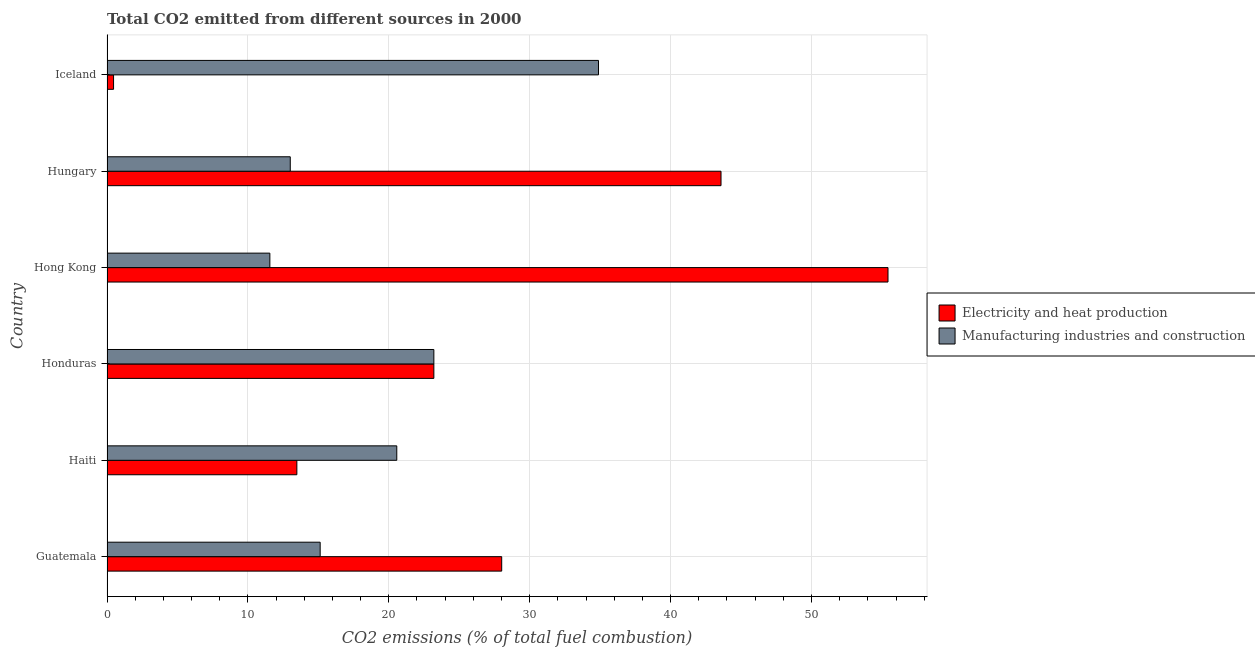How many different coloured bars are there?
Your answer should be compact. 2. How many groups of bars are there?
Your answer should be very brief. 6. What is the label of the 1st group of bars from the top?
Give a very brief answer. Iceland. In how many cases, is the number of bars for a given country not equal to the number of legend labels?
Your answer should be compact. 0. What is the co2 emissions due to electricity and heat production in Hong Kong?
Your answer should be very brief. 55.43. Across all countries, what is the maximum co2 emissions due to manufacturing industries?
Make the answer very short. 34.88. Across all countries, what is the minimum co2 emissions due to manufacturing industries?
Offer a terse response. 11.56. In which country was the co2 emissions due to manufacturing industries maximum?
Offer a terse response. Iceland. What is the total co2 emissions due to manufacturing industries in the graph?
Provide a succinct answer. 118.35. What is the difference between the co2 emissions due to manufacturing industries in Guatemala and that in Hong Kong?
Make the answer very short. 3.57. What is the difference between the co2 emissions due to manufacturing industries in Guatemala and the co2 emissions due to electricity and heat production in Iceland?
Make the answer very short. 14.66. What is the average co2 emissions due to electricity and heat production per country?
Your answer should be very brief. 27.36. What is the difference between the co2 emissions due to manufacturing industries and co2 emissions due to electricity and heat production in Haiti?
Ensure brevity in your answer.  7.09. What is the ratio of the co2 emissions due to electricity and heat production in Haiti to that in Hong Kong?
Offer a very short reply. 0.24. Is the co2 emissions due to electricity and heat production in Honduras less than that in Hong Kong?
Your answer should be compact. Yes. What is the difference between the highest and the second highest co2 emissions due to electricity and heat production?
Ensure brevity in your answer.  11.85. What is the difference between the highest and the lowest co2 emissions due to manufacturing industries?
Ensure brevity in your answer.  23.33. Is the sum of the co2 emissions due to electricity and heat production in Haiti and Hong Kong greater than the maximum co2 emissions due to manufacturing industries across all countries?
Your answer should be compact. Yes. What does the 2nd bar from the top in Hungary represents?
Give a very brief answer. Electricity and heat production. What does the 1st bar from the bottom in Guatemala represents?
Your response must be concise. Electricity and heat production. How many bars are there?
Ensure brevity in your answer.  12. How many countries are there in the graph?
Keep it short and to the point. 6. What is the difference between two consecutive major ticks on the X-axis?
Your answer should be compact. 10. Does the graph contain grids?
Offer a very short reply. Yes. What is the title of the graph?
Your answer should be very brief. Total CO2 emitted from different sources in 2000. Does "Male labor force" appear as one of the legend labels in the graph?
Your answer should be compact. No. What is the label or title of the X-axis?
Keep it short and to the point. CO2 emissions (% of total fuel combustion). What is the CO2 emissions (% of total fuel combustion) of Electricity and heat production in Guatemala?
Keep it short and to the point. 28.01. What is the CO2 emissions (% of total fuel combustion) of Manufacturing industries and construction in Guatemala?
Make the answer very short. 15.13. What is the CO2 emissions (% of total fuel combustion) in Electricity and heat production in Haiti?
Offer a terse response. 13.48. What is the CO2 emissions (% of total fuel combustion) of Manufacturing industries and construction in Haiti?
Provide a short and direct response. 20.57. What is the CO2 emissions (% of total fuel combustion) in Electricity and heat production in Honduras?
Your answer should be compact. 23.2. What is the CO2 emissions (% of total fuel combustion) in Manufacturing industries and construction in Honduras?
Give a very brief answer. 23.2. What is the CO2 emissions (% of total fuel combustion) of Electricity and heat production in Hong Kong?
Provide a short and direct response. 55.43. What is the CO2 emissions (% of total fuel combustion) in Manufacturing industries and construction in Hong Kong?
Your answer should be compact. 11.56. What is the CO2 emissions (% of total fuel combustion) in Electricity and heat production in Hungary?
Provide a succinct answer. 43.58. What is the CO2 emissions (% of total fuel combustion) in Manufacturing industries and construction in Hungary?
Give a very brief answer. 13.01. What is the CO2 emissions (% of total fuel combustion) in Electricity and heat production in Iceland?
Give a very brief answer. 0.47. What is the CO2 emissions (% of total fuel combustion) in Manufacturing industries and construction in Iceland?
Provide a short and direct response. 34.88. Across all countries, what is the maximum CO2 emissions (% of total fuel combustion) of Electricity and heat production?
Offer a very short reply. 55.43. Across all countries, what is the maximum CO2 emissions (% of total fuel combustion) of Manufacturing industries and construction?
Provide a short and direct response. 34.88. Across all countries, what is the minimum CO2 emissions (% of total fuel combustion) in Electricity and heat production?
Make the answer very short. 0.47. Across all countries, what is the minimum CO2 emissions (% of total fuel combustion) in Manufacturing industries and construction?
Provide a short and direct response. 11.56. What is the total CO2 emissions (% of total fuel combustion) of Electricity and heat production in the graph?
Your response must be concise. 164.16. What is the total CO2 emissions (% of total fuel combustion) of Manufacturing industries and construction in the graph?
Offer a very short reply. 118.35. What is the difference between the CO2 emissions (% of total fuel combustion) in Electricity and heat production in Guatemala and that in Haiti?
Give a very brief answer. 14.54. What is the difference between the CO2 emissions (% of total fuel combustion) in Manufacturing industries and construction in Guatemala and that in Haiti?
Provide a short and direct response. -5.44. What is the difference between the CO2 emissions (% of total fuel combustion) of Electricity and heat production in Guatemala and that in Honduras?
Keep it short and to the point. 4.82. What is the difference between the CO2 emissions (% of total fuel combustion) in Manufacturing industries and construction in Guatemala and that in Honduras?
Offer a very short reply. -8.07. What is the difference between the CO2 emissions (% of total fuel combustion) of Electricity and heat production in Guatemala and that in Hong Kong?
Provide a succinct answer. -27.42. What is the difference between the CO2 emissions (% of total fuel combustion) in Manufacturing industries and construction in Guatemala and that in Hong Kong?
Give a very brief answer. 3.57. What is the difference between the CO2 emissions (% of total fuel combustion) in Electricity and heat production in Guatemala and that in Hungary?
Provide a short and direct response. -15.57. What is the difference between the CO2 emissions (% of total fuel combustion) of Manufacturing industries and construction in Guatemala and that in Hungary?
Your answer should be compact. 2.12. What is the difference between the CO2 emissions (% of total fuel combustion) in Electricity and heat production in Guatemala and that in Iceland?
Your answer should be very brief. 27.55. What is the difference between the CO2 emissions (% of total fuel combustion) of Manufacturing industries and construction in Guatemala and that in Iceland?
Keep it short and to the point. -19.75. What is the difference between the CO2 emissions (% of total fuel combustion) in Electricity and heat production in Haiti and that in Honduras?
Offer a terse response. -9.72. What is the difference between the CO2 emissions (% of total fuel combustion) of Manufacturing industries and construction in Haiti and that in Honduras?
Ensure brevity in your answer.  -2.63. What is the difference between the CO2 emissions (% of total fuel combustion) in Electricity and heat production in Haiti and that in Hong Kong?
Ensure brevity in your answer.  -41.96. What is the difference between the CO2 emissions (% of total fuel combustion) of Manufacturing industries and construction in Haiti and that in Hong Kong?
Your answer should be compact. 9.01. What is the difference between the CO2 emissions (% of total fuel combustion) of Electricity and heat production in Haiti and that in Hungary?
Ensure brevity in your answer.  -30.1. What is the difference between the CO2 emissions (% of total fuel combustion) in Manufacturing industries and construction in Haiti and that in Hungary?
Make the answer very short. 7.56. What is the difference between the CO2 emissions (% of total fuel combustion) in Electricity and heat production in Haiti and that in Iceland?
Ensure brevity in your answer.  13.01. What is the difference between the CO2 emissions (% of total fuel combustion) of Manufacturing industries and construction in Haiti and that in Iceland?
Keep it short and to the point. -14.32. What is the difference between the CO2 emissions (% of total fuel combustion) in Electricity and heat production in Honduras and that in Hong Kong?
Offer a terse response. -32.23. What is the difference between the CO2 emissions (% of total fuel combustion) in Manufacturing industries and construction in Honduras and that in Hong Kong?
Offer a terse response. 11.64. What is the difference between the CO2 emissions (% of total fuel combustion) in Electricity and heat production in Honduras and that in Hungary?
Ensure brevity in your answer.  -20.38. What is the difference between the CO2 emissions (% of total fuel combustion) of Manufacturing industries and construction in Honduras and that in Hungary?
Offer a very short reply. 10.19. What is the difference between the CO2 emissions (% of total fuel combustion) of Electricity and heat production in Honduras and that in Iceland?
Your response must be concise. 22.73. What is the difference between the CO2 emissions (% of total fuel combustion) of Manufacturing industries and construction in Honduras and that in Iceland?
Your answer should be compact. -11.69. What is the difference between the CO2 emissions (% of total fuel combustion) of Electricity and heat production in Hong Kong and that in Hungary?
Give a very brief answer. 11.85. What is the difference between the CO2 emissions (% of total fuel combustion) of Manufacturing industries and construction in Hong Kong and that in Hungary?
Your answer should be compact. -1.45. What is the difference between the CO2 emissions (% of total fuel combustion) of Electricity and heat production in Hong Kong and that in Iceland?
Your answer should be compact. 54.97. What is the difference between the CO2 emissions (% of total fuel combustion) in Manufacturing industries and construction in Hong Kong and that in Iceland?
Provide a short and direct response. -23.33. What is the difference between the CO2 emissions (% of total fuel combustion) in Electricity and heat production in Hungary and that in Iceland?
Ensure brevity in your answer.  43.11. What is the difference between the CO2 emissions (% of total fuel combustion) in Manufacturing industries and construction in Hungary and that in Iceland?
Give a very brief answer. -21.88. What is the difference between the CO2 emissions (% of total fuel combustion) of Electricity and heat production in Guatemala and the CO2 emissions (% of total fuel combustion) of Manufacturing industries and construction in Haiti?
Keep it short and to the point. 7.45. What is the difference between the CO2 emissions (% of total fuel combustion) in Electricity and heat production in Guatemala and the CO2 emissions (% of total fuel combustion) in Manufacturing industries and construction in Honduras?
Give a very brief answer. 4.82. What is the difference between the CO2 emissions (% of total fuel combustion) of Electricity and heat production in Guatemala and the CO2 emissions (% of total fuel combustion) of Manufacturing industries and construction in Hong Kong?
Offer a terse response. 16.46. What is the difference between the CO2 emissions (% of total fuel combustion) of Electricity and heat production in Guatemala and the CO2 emissions (% of total fuel combustion) of Manufacturing industries and construction in Hungary?
Ensure brevity in your answer.  15.01. What is the difference between the CO2 emissions (% of total fuel combustion) in Electricity and heat production in Guatemala and the CO2 emissions (% of total fuel combustion) in Manufacturing industries and construction in Iceland?
Offer a terse response. -6.87. What is the difference between the CO2 emissions (% of total fuel combustion) in Electricity and heat production in Haiti and the CO2 emissions (% of total fuel combustion) in Manufacturing industries and construction in Honduras?
Your response must be concise. -9.72. What is the difference between the CO2 emissions (% of total fuel combustion) of Electricity and heat production in Haiti and the CO2 emissions (% of total fuel combustion) of Manufacturing industries and construction in Hong Kong?
Give a very brief answer. 1.92. What is the difference between the CO2 emissions (% of total fuel combustion) of Electricity and heat production in Haiti and the CO2 emissions (% of total fuel combustion) of Manufacturing industries and construction in Hungary?
Provide a short and direct response. 0.47. What is the difference between the CO2 emissions (% of total fuel combustion) in Electricity and heat production in Haiti and the CO2 emissions (% of total fuel combustion) in Manufacturing industries and construction in Iceland?
Offer a terse response. -21.41. What is the difference between the CO2 emissions (% of total fuel combustion) in Electricity and heat production in Honduras and the CO2 emissions (% of total fuel combustion) in Manufacturing industries and construction in Hong Kong?
Provide a short and direct response. 11.64. What is the difference between the CO2 emissions (% of total fuel combustion) in Electricity and heat production in Honduras and the CO2 emissions (% of total fuel combustion) in Manufacturing industries and construction in Hungary?
Give a very brief answer. 10.19. What is the difference between the CO2 emissions (% of total fuel combustion) in Electricity and heat production in Honduras and the CO2 emissions (% of total fuel combustion) in Manufacturing industries and construction in Iceland?
Keep it short and to the point. -11.69. What is the difference between the CO2 emissions (% of total fuel combustion) in Electricity and heat production in Hong Kong and the CO2 emissions (% of total fuel combustion) in Manufacturing industries and construction in Hungary?
Give a very brief answer. 42.42. What is the difference between the CO2 emissions (% of total fuel combustion) of Electricity and heat production in Hong Kong and the CO2 emissions (% of total fuel combustion) of Manufacturing industries and construction in Iceland?
Offer a terse response. 20.55. What is the difference between the CO2 emissions (% of total fuel combustion) in Electricity and heat production in Hungary and the CO2 emissions (% of total fuel combustion) in Manufacturing industries and construction in Iceland?
Your answer should be compact. 8.7. What is the average CO2 emissions (% of total fuel combustion) in Electricity and heat production per country?
Keep it short and to the point. 27.36. What is the average CO2 emissions (% of total fuel combustion) in Manufacturing industries and construction per country?
Your response must be concise. 19.72. What is the difference between the CO2 emissions (% of total fuel combustion) in Electricity and heat production and CO2 emissions (% of total fuel combustion) in Manufacturing industries and construction in Guatemala?
Make the answer very short. 12.88. What is the difference between the CO2 emissions (% of total fuel combustion) of Electricity and heat production and CO2 emissions (% of total fuel combustion) of Manufacturing industries and construction in Haiti?
Your answer should be compact. -7.09. What is the difference between the CO2 emissions (% of total fuel combustion) in Electricity and heat production and CO2 emissions (% of total fuel combustion) in Manufacturing industries and construction in Honduras?
Keep it short and to the point. 0. What is the difference between the CO2 emissions (% of total fuel combustion) of Electricity and heat production and CO2 emissions (% of total fuel combustion) of Manufacturing industries and construction in Hong Kong?
Offer a very short reply. 43.87. What is the difference between the CO2 emissions (% of total fuel combustion) of Electricity and heat production and CO2 emissions (% of total fuel combustion) of Manufacturing industries and construction in Hungary?
Your response must be concise. 30.57. What is the difference between the CO2 emissions (% of total fuel combustion) of Electricity and heat production and CO2 emissions (% of total fuel combustion) of Manufacturing industries and construction in Iceland?
Provide a succinct answer. -34.42. What is the ratio of the CO2 emissions (% of total fuel combustion) of Electricity and heat production in Guatemala to that in Haiti?
Your answer should be very brief. 2.08. What is the ratio of the CO2 emissions (% of total fuel combustion) of Manufacturing industries and construction in Guatemala to that in Haiti?
Provide a succinct answer. 0.74. What is the ratio of the CO2 emissions (% of total fuel combustion) of Electricity and heat production in Guatemala to that in Honduras?
Make the answer very short. 1.21. What is the ratio of the CO2 emissions (% of total fuel combustion) of Manufacturing industries and construction in Guatemala to that in Honduras?
Your answer should be compact. 0.65. What is the ratio of the CO2 emissions (% of total fuel combustion) in Electricity and heat production in Guatemala to that in Hong Kong?
Keep it short and to the point. 0.51. What is the ratio of the CO2 emissions (% of total fuel combustion) in Manufacturing industries and construction in Guatemala to that in Hong Kong?
Your response must be concise. 1.31. What is the ratio of the CO2 emissions (% of total fuel combustion) of Electricity and heat production in Guatemala to that in Hungary?
Your answer should be compact. 0.64. What is the ratio of the CO2 emissions (% of total fuel combustion) in Manufacturing industries and construction in Guatemala to that in Hungary?
Keep it short and to the point. 1.16. What is the ratio of the CO2 emissions (% of total fuel combustion) of Electricity and heat production in Guatemala to that in Iceland?
Ensure brevity in your answer.  60.23. What is the ratio of the CO2 emissions (% of total fuel combustion) in Manufacturing industries and construction in Guatemala to that in Iceland?
Keep it short and to the point. 0.43. What is the ratio of the CO2 emissions (% of total fuel combustion) of Electricity and heat production in Haiti to that in Honduras?
Make the answer very short. 0.58. What is the ratio of the CO2 emissions (% of total fuel combustion) in Manufacturing industries and construction in Haiti to that in Honduras?
Offer a terse response. 0.89. What is the ratio of the CO2 emissions (% of total fuel combustion) in Electricity and heat production in Haiti to that in Hong Kong?
Offer a very short reply. 0.24. What is the ratio of the CO2 emissions (% of total fuel combustion) of Manufacturing industries and construction in Haiti to that in Hong Kong?
Your answer should be very brief. 1.78. What is the ratio of the CO2 emissions (% of total fuel combustion) in Electricity and heat production in Haiti to that in Hungary?
Make the answer very short. 0.31. What is the ratio of the CO2 emissions (% of total fuel combustion) in Manufacturing industries and construction in Haiti to that in Hungary?
Offer a terse response. 1.58. What is the ratio of the CO2 emissions (% of total fuel combustion) of Electricity and heat production in Haiti to that in Iceland?
Your response must be concise. 28.97. What is the ratio of the CO2 emissions (% of total fuel combustion) in Manufacturing industries and construction in Haiti to that in Iceland?
Keep it short and to the point. 0.59. What is the ratio of the CO2 emissions (% of total fuel combustion) in Electricity and heat production in Honduras to that in Hong Kong?
Make the answer very short. 0.42. What is the ratio of the CO2 emissions (% of total fuel combustion) of Manufacturing industries and construction in Honduras to that in Hong Kong?
Give a very brief answer. 2.01. What is the ratio of the CO2 emissions (% of total fuel combustion) in Electricity and heat production in Honduras to that in Hungary?
Your answer should be very brief. 0.53. What is the ratio of the CO2 emissions (% of total fuel combustion) in Manufacturing industries and construction in Honduras to that in Hungary?
Give a very brief answer. 1.78. What is the ratio of the CO2 emissions (% of total fuel combustion) in Electricity and heat production in Honduras to that in Iceland?
Make the answer very short. 49.88. What is the ratio of the CO2 emissions (% of total fuel combustion) in Manufacturing industries and construction in Honduras to that in Iceland?
Give a very brief answer. 0.67. What is the ratio of the CO2 emissions (% of total fuel combustion) in Electricity and heat production in Hong Kong to that in Hungary?
Give a very brief answer. 1.27. What is the ratio of the CO2 emissions (% of total fuel combustion) in Manufacturing industries and construction in Hong Kong to that in Hungary?
Offer a terse response. 0.89. What is the ratio of the CO2 emissions (% of total fuel combustion) of Electricity and heat production in Hong Kong to that in Iceland?
Your answer should be very brief. 119.18. What is the ratio of the CO2 emissions (% of total fuel combustion) in Manufacturing industries and construction in Hong Kong to that in Iceland?
Offer a very short reply. 0.33. What is the ratio of the CO2 emissions (% of total fuel combustion) in Electricity and heat production in Hungary to that in Iceland?
Make the answer very short. 93.7. What is the ratio of the CO2 emissions (% of total fuel combustion) in Manufacturing industries and construction in Hungary to that in Iceland?
Provide a succinct answer. 0.37. What is the difference between the highest and the second highest CO2 emissions (% of total fuel combustion) in Electricity and heat production?
Your answer should be very brief. 11.85. What is the difference between the highest and the second highest CO2 emissions (% of total fuel combustion) of Manufacturing industries and construction?
Give a very brief answer. 11.69. What is the difference between the highest and the lowest CO2 emissions (% of total fuel combustion) of Electricity and heat production?
Keep it short and to the point. 54.97. What is the difference between the highest and the lowest CO2 emissions (% of total fuel combustion) of Manufacturing industries and construction?
Make the answer very short. 23.33. 